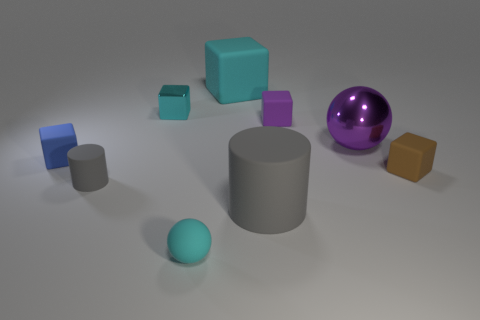There is a sphere that is made of the same material as the small gray cylinder; what is its size?
Provide a short and direct response. Small. There is a shiny thing behind the small purple thing; does it have the same size as the block that is on the right side of the small purple matte cube?
Provide a short and direct response. Yes. How many objects are purple rubber blocks or purple metallic spheres?
Ensure brevity in your answer.  2. There is a cyan metallic object; what shape is it?
Your answer should be very brief. Cube. There is another matte thing that is the same shape as the large purple thing; what size is it?
Your answer should be compact. Small. Is there any other thing that has the same material as the blue block?
Offer a very short reply. Yes. There is a ball on the left side of the matte object behind the cyan metal block; how big is it?
Give a very brief answer. Small. Are there an equal number of rubber blocks that are in front of the big cyan thing and big yellow rubber spheres?
Keep it short and to the point. No. What number of other things are the same color as the big rubber cylinder?
Ensure brevity in your answer.  1. Is the number of small cyan things in front of the tiny cyan ball less than the number of tiny rubber spheres?
Your answer should be compact. Yes. 